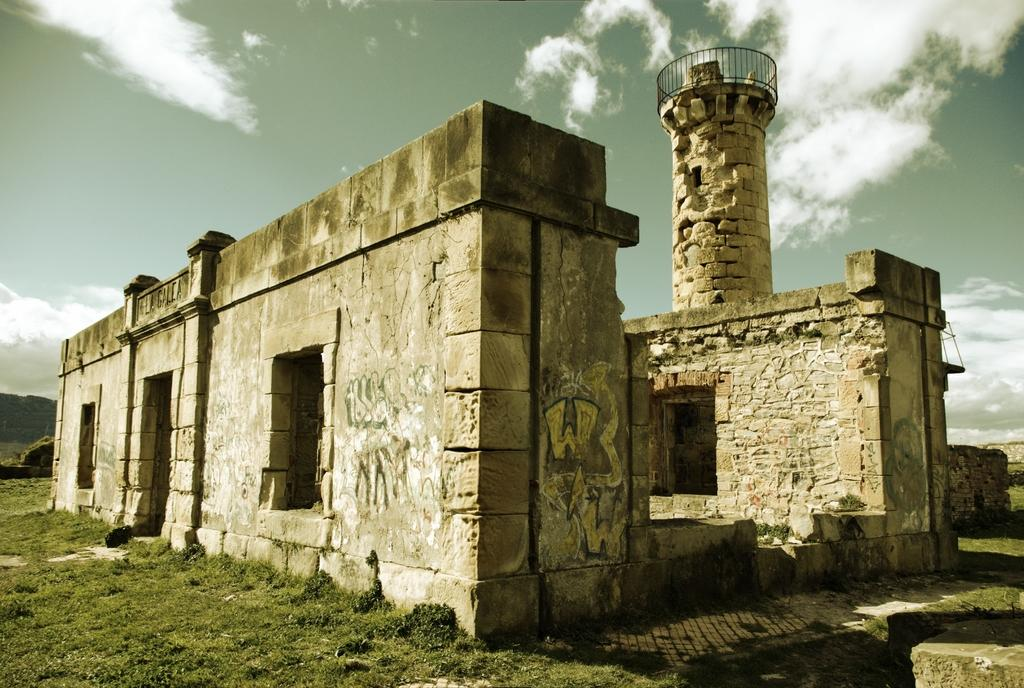What is the main subject of the picture? There is a monument in the picture. What type of ground is visible in the image? There is grass on the ground. How would you describe the sky in the picture? The sky is cloudy. What is the position of the surprise in the image? There is no surprise present in the image. Can you tell me the time of day when the picture was taken? The provided facts do not give any information about the time of day when the picture was taken. 